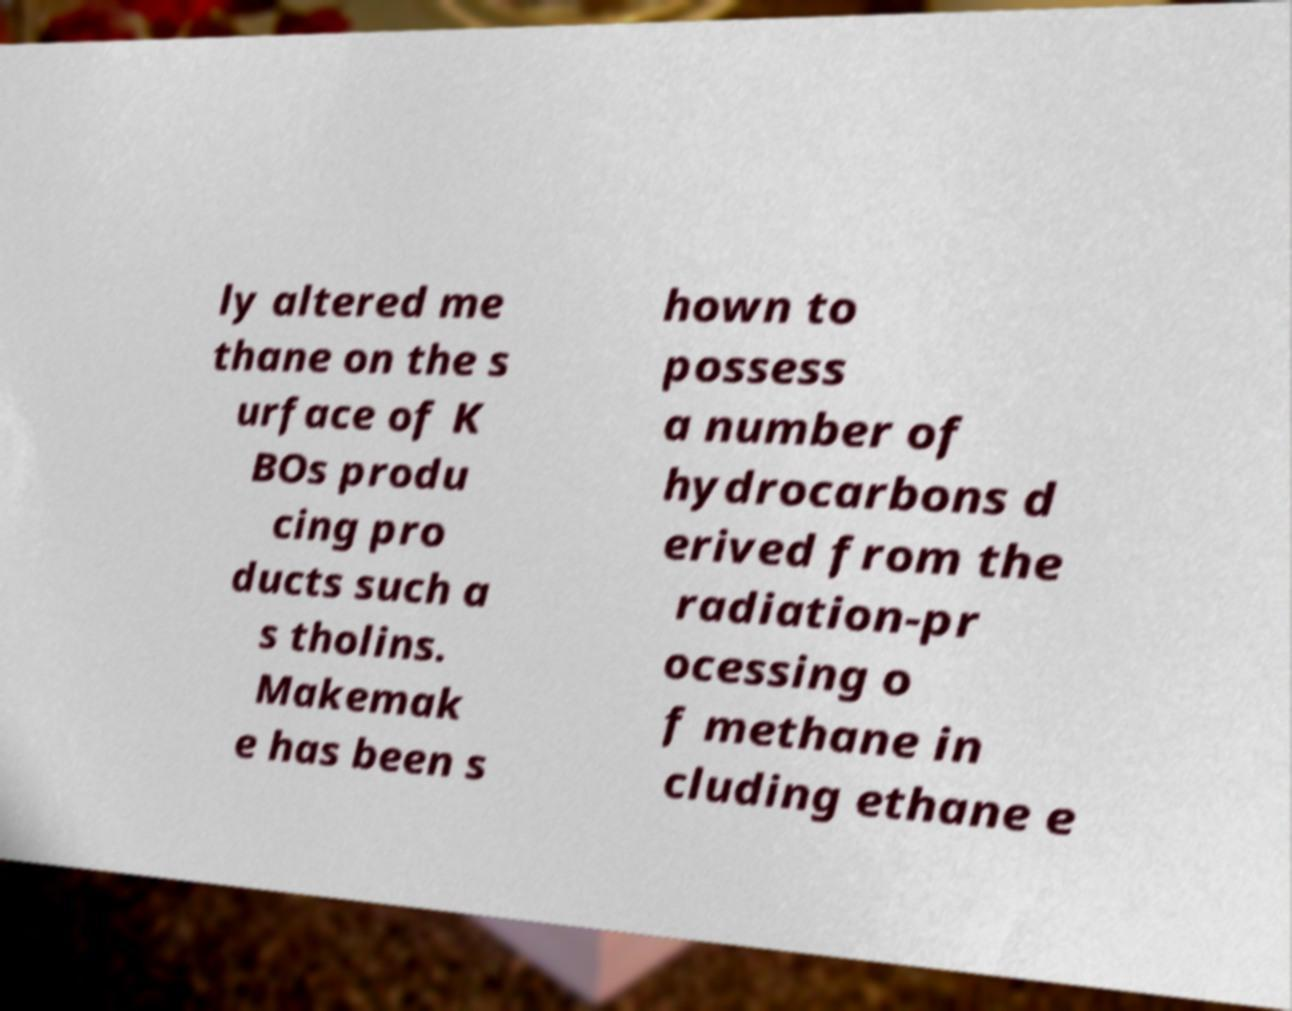Can you accurately transcribe the text from the provided image for me? ly altered me thane on the s urface of K BOs produ cing pro ducts such a s tholins. Makemak e has been s hown to possess a number of hydrocarbons d erived from the radiation-pr ocessing o f methane in cluding ethane e 